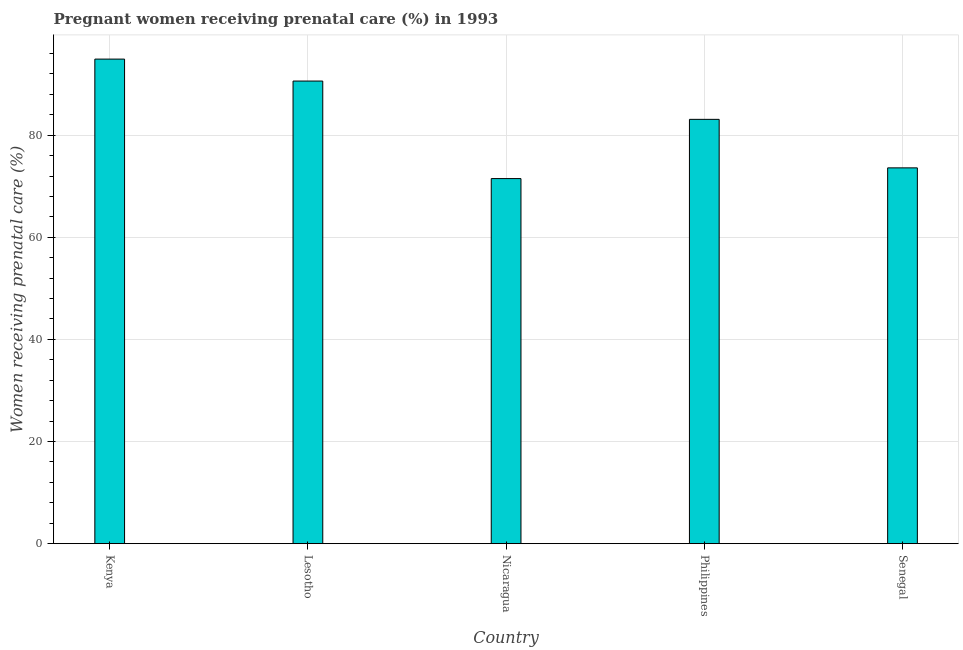Does the graph contain any zero values?
Give a very brief answer. No. Does the graph contain grids?
Offer a terse response. Yes. What is the title of the graph?
Offer a terse response. Pregnant women receiving prenatal care (%) in 1993. What is the label or title of the X-axis?
Your answer should be very brief. Country. What is the label or title of the Y-axis?
Your answer should be very brief. Women receiving prenatal care (%). What is the percentage of pregnant women receiving prenatal care in Lesotho?
Provide a short and direct response. 90.6. Across all countries, what is the maximum percentage of pregnant women receiving prenatal care?
Make the answer very short. 94.9. Across all countries, what is the minimum percentage of pregnant women receiving prenatal care?
Provide a succinct answer. 71.5. In which country was the percentage of pregnant women receiving prenatal care maximum?
Your answer should be compact. Kenya. In which country was the percentage of pregnant women receiving prenatal care minimum?
Ensure brevity in your answer.  Nicaragua. What is the sum of the percentage of pregnant women receiving prenatal care?
Your answer should be compact. 413.7. What is the average percentage of pregnant women receiving prenatal care per country?
Provide a short and direct response. 82.74. What is the median percentage of pregnant women receiving prenatal care?
Keep it short and to the point. 83.1. Is the difference between the percentage of pregnant women receiving prenatal care in Kenya and Nicaragua greater than the difference between any two countries?
Provide a succinct answer. Yes. What is the difference between the highest and the lowest percentage of pregnant women receiving prenatal care?
Provide a succinct answer. 23.4. In how many countries, is the percentage of pregnant women receiving prenatal care greater than the average percentage of pregnant women receiving prenatal care taken over all countries?
Provide a succinct answer. 3. How many bars are there?
Your answer should be compact. 5. How many countries are there in the graph?
Offer a terse response. 5. What is the Women receiving prenatal care (%) in Kenya?
Provide a short and direct response. 94.9. What is the Women receiving prenatal care (%) in Lesotho?
Give a very brief answer. 90.6. What is the Women receiving prenatal care (%) of Nicaragua?
Keep it short and to the point. 71.5. What is the Women receiving prenatal care (%) of Philippines?
Ensure brevity in your answer.  83.1. What is the Women receiving prenatal care (%) in Senegal?
Ensure brevity in your answer.  73.6. What is the difference between the Women receiving prenatal care (%) in Kenya and Lesotho?
Provide a succinct answer. 4.3. What is the difference between the Women receiving prenatal care (%) in Kenya and Nicaragua?
Make the answer very short. 23.4. What is the difference between the Women receiving prenatal care (%) in Kenya and Senegal?
Ensure brevity in your answer.  21.3. What is the difference between the Women receiving prenatal care (%) in Lesotho and Nicaragua?
Give a very brief answer. 19.1. What is the difference between the Women receiving prenatal care (%) in Lesotho and Philippines?
Keep it short and to the point. 7.5. What is the difference between the Women receiving prenatal care (%) in Lesotho and Senegal?
Provide a short and direct response. 17. What is the ratio of the Women receiving prenatal care (%) in Kenya to that in Lesotho?
Offer a very short reply. 1.05. What is the ratio of the Women receiving prenatal care (%) in Kenya to that in Nicaragua?
Keep it short and to the point. 1.33. What is the ratio of the Women receiving prenatal care (%) in Kenya to that in Philippines?
Make the answer very short. 1.14. What is the ratio of the Women receiving prenatal care (%) in Kenya to that in Senegal?
Your response must be concise. 1.29. What is the ratio of the Women receiving prenatal care (%) in Lesotho to that in Nicaragua?
Offer a terse response. 1.27. What is the ratio of the Women receiving prenatal care (%) in Lesotho to that in Philippines?
Keep it short and to the point. 1.09. What is the ratio of the Women receiving prenatal care (%) in Lesotho to that in Senegal?
Give a very brief answer. 1.23. What is the ratio of the Women receiving prenatal care (%) in Nicaragua to that in Philippines?
Offer a very short reply. 0.86. What is the ratio of the Women receiving prenatal care (%) in Nicaragua to that in Senegal?
Keep it short and to the point. 0.97. What is the ratio of the Women receiving prenatal care (%) in Philippines to that in Senegal?
Give a very brief answer. 1.13. 